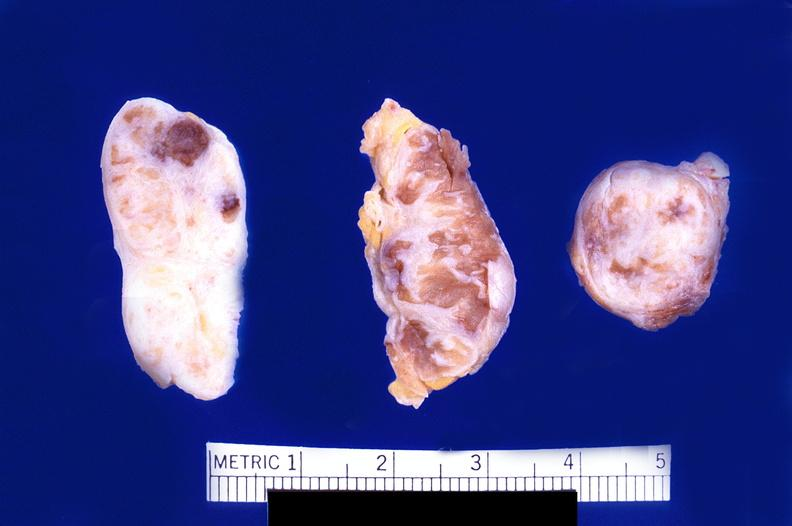what does this image show?
Answer the question using a single word or phrase. Abdominal lymph nodes 